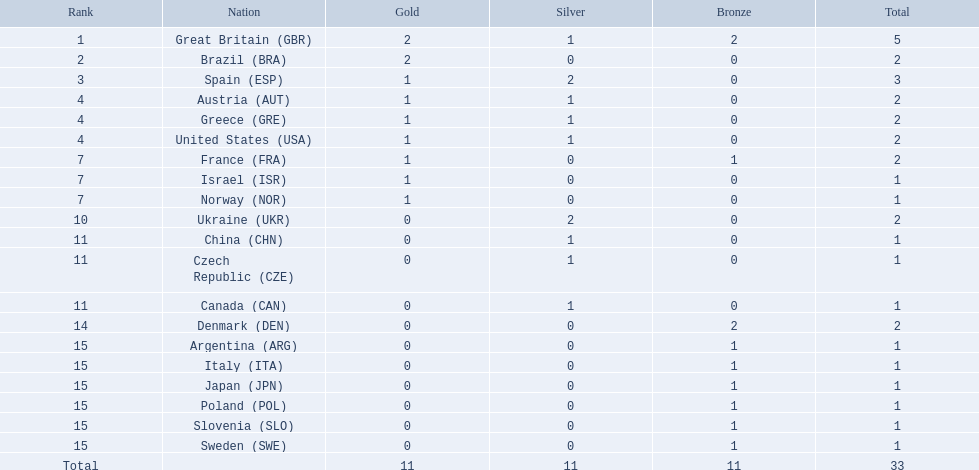What quantity of medals did each nation earn? 5, 2, 3, 2, 2, 2, 2, 1, 1, 2, 1, 1, 1, 2, 1, 1, 1, 1, 1, 1. Which nation secured 3 medals? Spain (ESP). Could you help me parse every detail presented in this table? {'header': ['Rank', 'Nation', 'Gold', 'Silver', 'Bronze', 'Total'], 'rows': [['1', 'Great Britain\xa0(GBR)', '2', '1', '2', '5'], ['2', 'Brazil\xa0(BRA)', '2', '0', '0', '2'], ['3', 'Spain\xa0(ESP)', '1', '2', '0', '3'], ['4', 'Austria\xa0(AUT)', '1', '1', '0', '2'], ['4', 'Greece\xa0(GRE)', '1', '1', '0', '2'], ['4', 'United States\xa0(USA)', '1', '1', '0', '2'], ['7', 'France\xa0(FRA)', '1', '0', '1', '2'], ['7', 'Israel\xa0(ISR)', '1', '0', '0', '1'], ['7', 'Norway\xa0(NOR)', '1', '0', '0', '1'], ['10', 'Ukraine\xa0(UKR)', '0', '2', '0', '2'], ['11', 'China\xa0(CHN)', '0', '1', '0', '1'], ['11', 'Czech Republic\xa0(CZE)', '0', '1', '0', '1'], ['11', 'Canada\xa0(CAN)', '0', '1', '0', '1'], ['14', 'Denmark\xa0(DEN)', '0', '0', '2', '2'], ['15', 'Argentina\xa0(ARG)', '0', '0', '1', '1'], ['15', 'Italy\xa0(ITA)', '0', '0', '1', '1'], ['15', 'Japan\xa0(JPN)', '0', '0', '1', '1'], ['15', 'Poland\xa0(POL)', '0', '0', '1', '1'], ['15', 'Slovenia\xa0(SLO)', '0', '0', '1', '1'], ['15', 'Sweden\xa0(SWE)', '0', '0', '1', '1'], ['Total', '', '11', '11', '11', '33']]} What is the total number of medals awarded to each nation? 5, 2, 3, 2, 2, 2, 2, 1, 1, 2, 1, 1, 1, 2, 1, 1, 1, 1, 1, 1. Which nation obtained 3 medals? Spain (ESP). 